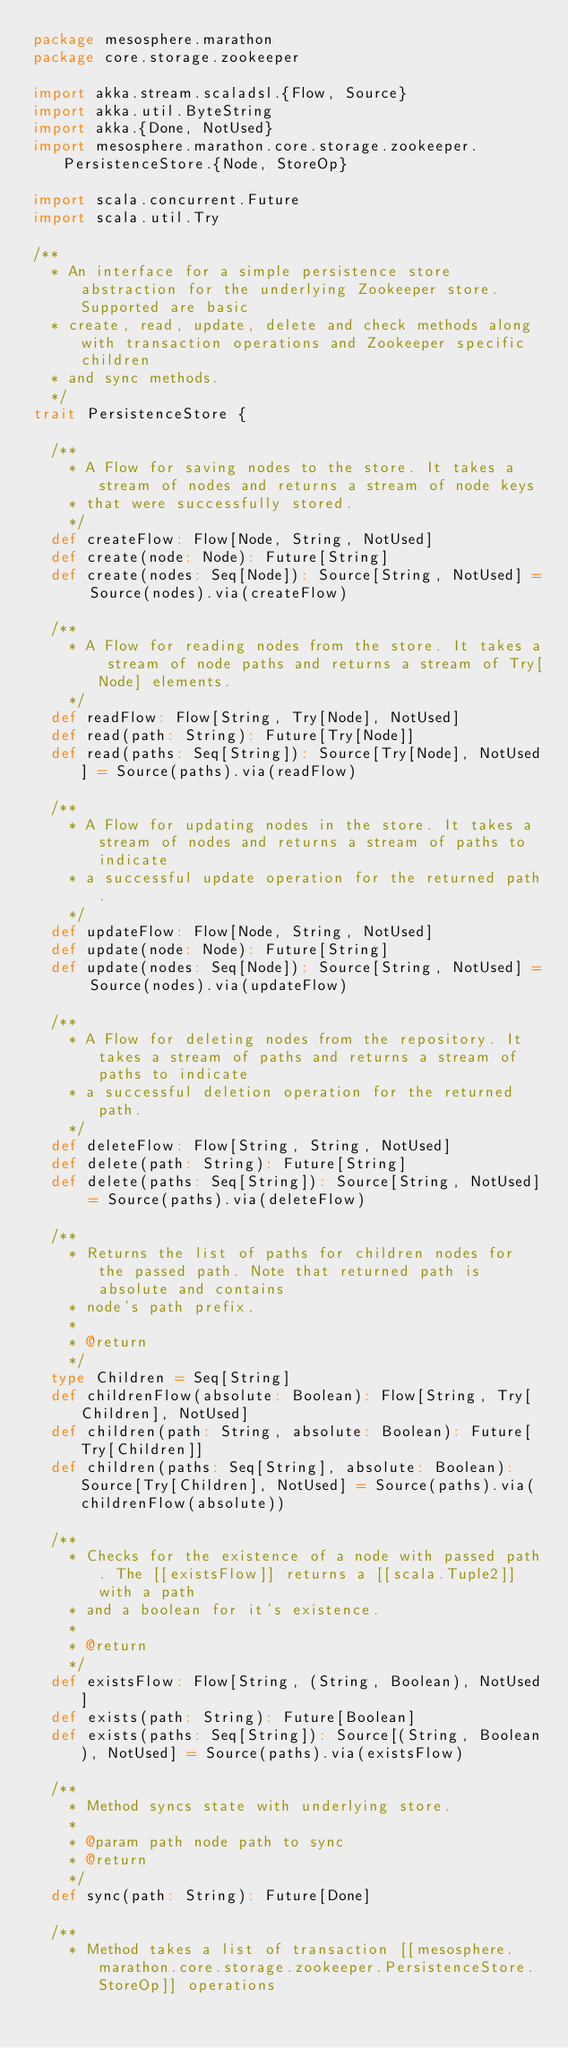Convert code to text. <code><loc_0><loc_0><loc_500><loc_500><_Scala_>package mesosphere.marathon
package core.storage.zookeeper

import akka.stream.scaladsl.{Flow, Source}
import akka.util.ByteString
import akka.{Done, NotUsed}
import mesosphere.marathon.core.storage.zookeeper.PersistenceStore.{Node, StoreOp}

import scala.concurrent.Future
import scala.util.Try

/**
  * An interface for a simple persistence store abstraction for the underlying Zookeeper store. Supported are basic
  * create, read, update, delete and check methods along with transaction operations and Zookeeper specific children
  * and sync methods.
  */
trait PersistenceStore {

  /**
    * A Flow for saving nodes to the store. It takes a stream of nodes and returns a stream of node keys
    * that were successfully stored.
    */
  def createFlow: Flow[Node, String, NotUsed]
  def create(node: Node): Future[String]
  def create(nodes: Seq[Node]): Source[String, NotUsed] = Source(nodes).via(createFlow)

  /**
    * A Flow for reading nodes from the store. It takes a stream of node paths and returns a stream of Try[Node] elements.
    */
  def readFlow: Flow[String, Try[Node], NotUsed]
  def read(path: String): Future[Try[Node]]
  def read(paths: Seq[String]): Source[Try[Node], NotUsed] = Source(paths).via(readFlow)

  /**
    * A Flow for updating nodes in the store. It takes a stream of nodes and returns a stream of paths to indicate
    * a successful update operation for the returned path.
    */
  def updateFlow: Flow[Node, String, NotUsed]
  def update(node: Node): Future[String]
  def update(nodes: Seq[Node]): Source[String, NotUsed] = Source(nodes).via(updateFlow)

  /**
    * A Flow for deleting nodes from the repository. It takes a stream of paths and returns a stream of paths to indicate
    * a successful deletion operation for the returned path.
    */
  def deleteFlow: Flow[String, String, NotUsed]
  def delete(path: String): Future[String]
  def delete(paths: Seq[String]): Source[String, NotUsed] = Source(paths).via(deleteFlow)

  /**
    * Returns the list of paths for children nodes for the passed path. Note that returned path is absolute and contains
    * node's path prefix.
    *
    * @return
    */
  type Children = Seq[String]
  def childrenFlow(absolute: Boolean): Flow[String, Try[Children], NotUsed]
  def children(path: String, absolute: Boolean): Future[Try[Children]]
  def children(paths: Seq[String], absolute: Boolean): Source[Try[Children], NotUsed] = Source(paths).via(childrenFlow(absolute))

  /**
    * Checks for the existence of a node with passed path. The [[existsFlow]] returns a [[scala.Tuple2]] with a path
    * and a boolean for it's existence.
    *
    * @return
    */
  def existsFlow: Flow[String, (String, Boolean), NotUsed]
  def exists(path: String): Future[Boolean]
  def exists(paths: Seq[String]): Source[(String, Boolean), NotUsed] = Source(paths).via(existsFlow)

  /**
    * Method syncs state with underlying store.
    *
    * @param path node path to sync
    * @return
    */
  def sync(path: String): Future[Done]

  /**
    * Method takes a list of transaction [[mesosphere.marathon.core.storage.zookeeper.PersistenceStore.StoreOp]] operations</code> 